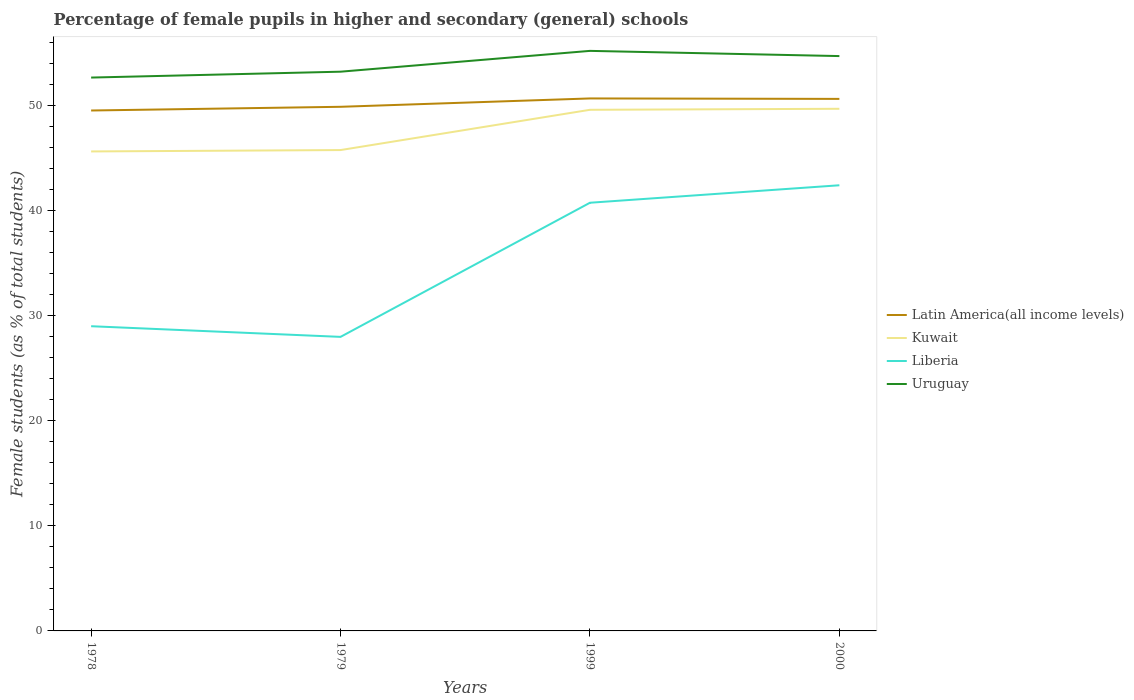How many different coloured lines are there?
Ensure brevity in your answer.  4. Does the line corresponding to Kuwait intersect with the line corresponding to Latin America(all income levels)?
Provide a succinct answer. No. Is the number of lines equal to the number of legend labels?
Provide a succinct answer. Yes. Across all years, what is the maximum percentage of female pupils in higher and secondary schools in Latin America(all income levels)?
Provide a short and direct response. 49.54. In which year was the percentage of female pupils in higher and secondary schools in Latin America(all income levels) maximum?
Ensure brevity in your answer.  1978. What is the total percentage of female pupils in higher and secondary schools in Liberia in the graph?
Ensure brevity in your answer.  -1.66. What is the difference between the highest and the second highest percentage of female pupils in higher and secondary schools in Latin America(all income levels)?
Offer a very short reply. 1.15. What is the difference between the highest and the lowest percentage of female pupils in higher and secondary schools in Kuwait?
Your answer should be compact. 2. Is the percentage of female pupils in higher and secondary schools in Uruguay strictly greater than the percentage of female pupils in higher and secondary schools in Latin America(all income levels) over the years?
Ensure brevity in your answer.  No. What is the difference between two consecutive major ticks on the Y-axis?
Keep it short and to the point. 10. Does the graph contain grids?
Ensure brevity in your answer.  No. Where does the legend appear in the graph?
Your answer should be compact. Center right. How many legend labels are there?
Give a very brief answer. 4. How are the legend labels stacked?
Provide a short and direct response. Vertical. What is the title of the graph?
Your response must be concise. Percentage of female pupils in higher and secondary (general) schools. Does "Guam" appear as one of the legend labels in the graph?
Your response must be concise. No. What is the label or title of the X-axis?
Your response must be concise. Years. What is the label or title of the Y-axis?
Your response must be concise. Female students (as % of total students). What is the Female students (as % of total students) of Latin America(all income levels) in 1978?
Give a very brief answer. 49.54. What is the Female students (as % of total students) of Kuwait in 1978?
Give a very brief answer. 45.65. What is the Female students (as % of total students) in Liberia in 1978?
Offer a very short reply. 29.01. What is the Female students (as % of total students) in Uruguay in 1978?
Your response must be concise. 52.68. What is the Female students (as % of total students) in Latin America(all income levels) in 1979?
Give a very brief answer. 49.89. What is the Female students (as % of total students) in Kuwait in 1979?
Ensure brevity in your answer.  45.78. What is the Female students (as % of total students) of Liberia in 1979?
Make the answer very short. 27.99. What is the Female students (as % of total students) in Uruguay in 1979?
Ensure brevity in your answer.  53.24. What is the Female students (as % of total students) of Latin America(all income levels) in 1999?
Offer a very short reply. 50.69. What is the Female students (as % of total students) of Kuwait in 1999?
Give a very brief answer. 49.61. What is the Female students (as % of total students) of Liberia in 1999?
Provide a short and direct response. 40.76. What is the Female students (as % of total students) in Uruguay in 1999?
Offer a terse response. 55.22. What is the Female students (as % of total students) of Latin America(all income levels) in 2000?
Give a very brief answer. 50.65. What is the Female students (as % of total students) of Kuwait in 2000?
Provide a succinct answer. 49.71. What is the Female students (as % of total students) of Liberia in 2000?
Offer a very short reply. 42.42. What is the Female students (as % of total students) in Uruguay in 2000?
Your answer should be very brief. 54.72. Across all years, what is the maximum Female students (as % of total students) of Latin America(all income levels)?
Your answer should be compact. 50.69. Across all years, what is the maximum Female students (as % of total students) of Kuwait?
Offer a terse response. 49.71. Across all years, what is the maximum Female students (as % of total students) in Liberia?
Ensure brevity in your answer.  42.42. Across all years, what is the maximum Female students (as % of total students) in Uruguay?
Provide a succinct answer. 55.22. Across all years, what is the minimum Female students (as % of total students) in Latin America(all income levels)?
Provide a succinct answer. 49.54. Across all years, what is the minimum Female students (as % of total students) in Kuwait?
Make the answer very short. 45.65. Across all years, what is the minimum Female students (as % of total students) in Liberia?
Ensure brevity in your answer.  27.99. Across all years, what is the minimum Female students (as % of total students) of Uruguay?
Provide a short and direct response. 52.68. What is the total Female students (as % of total students) of Latin America(all income levels) in the graph?
Your response must be concise. 200.78. What is the total Female students (as % of total students) of Kuwait in the graph?
Your response must be concise. 190.74. What is the total Female students (as % of total students) of Liberia in the graph?
Ensure brevity in your answer.  140.19. What is the total Female students (as % of total students) in Uruguay in the graph?
Keep it short and to the point. 215.86. What is the difference between the Female students (as % of total students) of Latin America(all income levels) in 1978 and that in 1979?
Provide a short and direct response. -0.35. What is the difference between the Female students (as % of total students) of Kuwait in 1978 and that in 1979?
Your answer should be very brief. -0.13. What is the difference between the Female students (as % of total students) of Liberia in 1978 and that in 1979?
Your answer should be compact. 1.01. What is the difference between the Female students (as % of total students) of Uruguay in 1978 and that in 1979?
Make the answer very short. -0.56. What is the difference between the Female students (as % of total students) in Latin America(all income levels) in 1978 and that in 1999?
Provide a succinct answer. -1.15. What is the difference between the Female students (as % of total students) in Kuwait in 1978 and that in 1999?
Provide a short and direct response. -3.96. What is the difference between the Female students (as % of total students) in Liberia in 1978 and that in 1999?
Offer a very short reply. -11.75. What is the difference between the Female students (as % of total students) in Uruguay in 1978 and that in 1999?
Offer a terse response. -2.54. What is the difference between the Female students (as % of total students) in Latin America(all income levels) in 1978 and that in 2000?
Keep it short and to the point. -1.11. What is the difference between the Female students (as % of total students) in Kuwait in 1978 and that in 2000?
Offer a terse response. -4.06. What is the difference between the Female students (as % of total students) in Liberia in 1978 and that in 2000?
Give a very brief answer. -13.42. What is the difference between the Female students (as % of total students) in Uruguay in 1978 and that in 2000?
Ensure brevity in your answer.  -2.05. What is the difference between the Female students (as % of total students) of Latin America(all income levels) in 1979 and that in 1999?
Your answer should be very brief. -0.8. What is the difference between the Female students (as % of total students) in Kuwait in 1979 and that in 1999?
Offer a terse response. -3.83. What is the difference between the Female students (as % of total students) in Liberia in 1979 and that in 1999?
Ensure brevity in your answer.  -12.77. What is the difference between the Female students (as % of total students) in Uruguay in 1979 and that in 1999?
Your answer should be very brief. -1.98. What is the difference between the Female students (as % of total students) of Latin America(all income levels) in 1979 and that in 2000?
Offer a terse response. -0.75. What is the difference between the Female students (as % of total students) of Kuwait in 1979 and that in 2000?
Your answer should be very brief. -3.93. What is the difference between the Female students (as % of total students) of Liberia in 1979 and that in 2000?
Provide a succinct answer. -14.43. What is the difference between the Female students (as % of total students) in Uruguay in 1979 and that in 2000?
Provide a succinct answer. -1.49. What is the difference between the Female students (as % of total students) in Latin America(all income levels) in 1999 and that in 2000?
Provide a short and direct response. 0.04. What is the difference between the Female students (as % of total students) of Kuwait in 1999 and that in 2000?
Keep it short and to the point. -0.1. What is the difference between the Female students (as % of total students) in Liberia in 1999 and that in 2000?
Offer a very short reply. -1.66. What is the difference between the Female students (as % of total students) in Uruguay in 1999 and that in 2000?
Your answer should be very brief. 0.49. What is the difference between the Female students (as % of total students) in Latin America(all income levels) in 1978 and the Female students (as % of total students) in Kuwait in 1979?
Provide a short and direct response. 3.77. What is the difference between the Female students (as % of total students) of Latin America(all income levels) in 1978 and the Female students (as % of total students) of Liberia in 1979?
Ensure brevity in your answer.  21.55. What is the difference between the Female students (as % of total students) in Latin America(all income levels) in 1978 and the Female students (as % of total students) in Uruguay in 1979?
Your response must be concise. -3.69. What is the difference between the Female students (as % of total students) in Kuwait in 1978 and the Female students (as % of total students) in Liberia in 1979?
Your response must be concise. 17.65. What is the difference between the Female students (as % of total students) in Kuwait in 1978 and the Female students (as % of total students) in Uruguay in 1979?
Your answer should be very brief. -7.59. What is the difference between the Female students (as % of total students) of Liberia in 1978 and the Female students (as % of total students) of Uruguay in 1979?
Provide a short and direct response. -24.23. What is the difference between the Female students (as % of total students) of Latin America(all income levels) in 1978 and the Female students (as % of total students) of Kuwait in 1999?
Offer a very short reply. -0.07. What is the difference between the Female students (as % of total students) in Latin America(all income levels) in 1978 and the Female students (as % of total students) in Liberia in 1999?
Provide a succinct answer. 8.78. What is the difference between the Female students (as % of total students) in Latin America(all income levels) in 1978 and the Female students (as % of total students) in Uruguay in 1999?
Your response must be concise. -5.68. What is the difference between the Female students (as % of total students) in Kuwait in 1978 and the Female students (as % of total students) in Liberia in 1999?
Provide a short and direct response. 4.88. What is the difference between the Female students (as % of total students) of Kuwait in 1978 and the Female students (as % of total students) of Uruguay in 1999?
Keep it short and to the point. -9.57. What is the difference between the Female students (as % of total students) of Liberia in 1978 and the Female students (as % of total students) of Uruguay in 1999?
Keep it short and to the point. -26.21. What is the difference between the Female students (as % of total students) in Latin America(all income levels) in 1978 and the Female students (as % of total students) in Kuwait in 2000?
Make the answer very short. -0.16. What is the difference between the Female students (as % of total students) of Latin America(all income levels) in 1978 and the Female students (as % of total students) of Liberia in 2000?
Keep it short and to the point. 7.12. What is the difference between the Female students (as % of total students) in Latin America(all income levels) in 1978 and the Female students (as % of total students) in Uruguay in 2000?
Offer a terse response. -5.18. What is the difference between the Female students (as % of total students) in Kuwait in 1978 and the Female students (as % of total students) in Liberia in 2000?
Give a very brief answer. 3.22. What is the difference between the Female students (as % of total students) in Kuwait in 1978 and the Female students (as % of total students) in Uruguay in 2000?
Ensure brevity in your answer.  -9.08. What is the difference between the Female students (as % of total students) of Liberia in 1978 and the Female students (as % of total students) of Uruguay in 2000?
Offer a very short reply. -25.72. What is the difference between the Female students (as % of total students) in Latin America(all income levels) in 1979 and the Female students (as % of total students) in Kuwait in 1999?
Your answer should be compact. 0.29. What is the difference between the Female students (as % of total students) of Latin America(all income levels) in 1979 and the Female students (as % of total students) of Liberia in 1999?
Your answer should be compact. 9.13. What is the difference between the Female students (as % of total students) of Latin America(all income levels) in 1979 and the Female students (as % of total students) of Uruguay in 1999?
Your answer should be very brief. -5.32. What is the difference between the Female students (as % of total students) of Kuwait in 1979 and the Female students (as % of total students) of Liberia in 1999?
Provide a succinct answer. 5.01. What is the difference between the Female students (as % of total students) of Kuwait in 1979 and the Female students (as % of total students) of Uruguay in 1999?
Provide a succinct answer. -9.44. What is the difference between the Female students (as % of total students) of Liberia in 1979 and the Female students (as % of total students) of Uruguay in 1999?
Your answer should be compact. -27.23. What is the difference between the Female students (as % of total students) in Latin America(all income levels) in 1979 and the Female students (as % of total students) in Kuwait in 2000?
Ensure brevity in your answer.  0.19. What is the difference between the Female students (as % of total students) of Latin America(all income levels) in 1979 and the Female students (as % of total students) of Liberia in 2000?
Your response must be concise. 7.47. What is the difference between the Female students (as % of total students) in Latin America(all income levels) in 1979 and the Female students (as % of total students) in Uruguay in 2000?
Offer a very short reply. -4.83. What is the difference between the Female students (as % of total students) in Kuwait in 1979 and the Female students (as % of total students) in Liberia in 2000?
Ensure brevity in your answer.  3.35. What is the difference between the Female students (as % of total students) of Kuwait in 1979 and the Female students (as % of total students) of Uruguay in 2000?
Keep it short and to the point. -8.95. What is the difference between the Female students (as % of total students) in Liberia in 1979 and the Female students (as % of total students) in Uruguay in 2000?
Keep it short and to the point. -26.73. What is the difference between the Female students (as % of total students) of Latin America(all income levels) in 1999 and the Female students (as % of total students) of Kuwait in 2000?
Your response must be concise. 0.98. What is the difference between the Female students (as % of total students) in Latin America(all income levels) in 1999 and the Female students (as % of total students) in Liberia in 2000?
Your response must be concise. 8.27. What is the difference between the Female students (as % of total students) of Latin America(all income levels) in 1999 and the Female students (as % of total students) of Uruguay in 2000?
Your answer should be compact. -4.03. What is the difference between the Female students (as % of total students) of Kuwait in 1999 and the Female students (as % of total students) of Liberia in 2000?
Make the answer very short. 7.18. What is the difference between the Female students (as % of total students) of Kuwait in 1999 and the Female students (as % of total students) of Uruguay in 2000?
Offer a very short reply. -5.11. What is the difference between the Female students (as % of total students) of Liberia in 1999 and the Female students (as % of total students) of Uruguay in 2000?
Provide a short and direct response. -13.96. What is the average Female students (as % of total students) in Latin America(all income levels) per year?
Give a very brief answer. 50.19. What is the average Female students (as % of total students) of Kuwait per year?
Keep it short and to the point. 47.68. What is the average Female students (as % of total students) in Liberia per year?
Give a very brief answer. 35.05. What is the average Female students (as % of total students) of Uruguay per year?
Offer a terse response. 53.96. In the year 1978, what is the difference between the Female students (as % of total students) in Latin America(all income levels) and Female students (as % of total students) in Kuwait?
Give a very brief answer. 3.9. In the year 1978, what is the difference between the Female students (as % of total students) of Latin America(all income levels) and Female students (as % of total students) of Liberia?
Your answer should be very brief. 20.54. In the year 1978, what is the difference between the Female students (as % of total students) in Latin America(all income levels) and Female students (as % of total students) in Uruguay?
Offer a very short reply. -3.14. In the year 1978, what is the difference between the Female students (as % of total students) of Kuwait and Female students (as % of total students) of Liberia?
Give a very brief answer. 16.64. In the year 1978, what is the difference between the Female students (as % of total students) of Kuwait and Female students (as % of total students) of Uruguay?
Keep it short and to the point. -7.03. In the year 1978, what is the difference between the Female students (as % of total students) in Liberia and Female students (as % of total students) in Uruguay?
Offer a very short reply. -23.67. In the year 1979, what is the difference between the Female students (as % of total students) of Latin America(all income levels) and Female students (as % of total students) of Kuwait?
Provide a short and direct response. 4.12. In the year 1979, what is the difference between the Female students (as % of total students) in Latin America(all income levels) and Female students (as % of total students) in Liberia?
Ensure brevity in your answer.  21.9. In the year 1979, what is the difference between the Female students (as % of total students) of Latin America(all income levels) and Female students (as % of total students) of Uruguay?
Provide a short and direct response. -3.34. In the year 1979, what is the difference between the Female students (as % of total students) of Kuwait and Female students (as % of total students) of Liberia?
Your answer should be very brief. 17.78. In the year 1979, what is the difference between the Female students (as % of total students) of Kuwait and Female students (as % of total students) of Uruguay?
Provide a succinct answer. -7.46. In the year 1979, what is the difference between the Female students (as % of total students) in Liberia and Female students (as % of total students) in Uruguay?
Offer a terse response. -25.24. In the year 1999, what is the difference between the Female students (as % of total students) in Latin America(all income levels) and Female students (as % of total students) in Kuwait?
Keep it short and to the point. 1.08. In the year 1999, what is the difference between the Female students (as % of total students) in Latin America(all income levels) and Female students (as % of total students) in Liberia?
Offer a terse response. 9.93. In the year 1999, what is the difference between the Female students (as % of total students) of Latin America(all income levels) and Female students (as % of total students) of Uruguay?
Provide a short and direct response. -4.53. In the year 1999, what is the difference between the Female students (as % of total students) in Kuwait and Female students (as % of total students) in Liberia?
Provide a succinct answer. 8.85. In the year 1999, what is the difference between the Female students (as % of total students) in Kuwait and Female students (as % of total students) in Uruguay?
Your answer should be very brief. -5.61. In the year 1999, what is the difference between the Female students (as % of total students) of Liberia and Female students (as % of total students) of Uruguay?
Provide a short and direct response. -14.46. In the year 2000, what is the difference between the Female students (as % of total students) in Latin America(all income levels) and Female students (as % of total students) in Kuwait?
Make the answer very short. 0.94. In the year 2000, what is the difference between the Female students (as % of total students) in Latin America(all income levels) and Female students (as % of total students) in Liberia?
Make the answer very short. 8.22. In the year 2000, what is the difference between the Female students (as % of total students) of Latin America(all income levels) and Female students (as % of total students) of Uruguay?
Your response must be concise. -4.08. In the year 2000, what is the difference between the Female students (as % of total students) of Kuwait and Female students (as % of total students) of Liberia?
Provide a succinct answer. 7.28. In the year 2000, what is the difference between the Female students (as % of total students) of Kuwait and Female students (as % of total students) of Uruguay?
Your answer should be very brief. -5.02. In the year 2000, what is the difference between the Female students (as % of total students) in Liberia and Female students (as % of total students) in Uruguay?
Your response must be concise. -12.3. What is the ratio of the Female students (as % of total students) in Latin America(all income levels) in 1978 to that in 1979?
Your response must be concise. 0.99. What is the ratio of the Female students (as % of total students) of Kuwait in 1978 to that in 1979?
Your answer should be compact. 1. What is the ratio of the Female students (as % of total students) in Liberia in 1978 to that in 1979?
Offer a very short reply. 1.04. What is the ratio of the Female students (as % of total students) in Latin America(all income levels) in 1978 to that in 1999?
Provide a succinct answer. 0.98. What is the ratio of the Female students (as % of total students) of Kuwait in 1978 to that in 1999?
Your response must be concise. 0.92. What is the ratio of the Female students (as % of total students) in Liberia in 1978 to that in 1999?
Make the answer very short. 0.71. What is the ratio of the Female students (as % of total students) in Uruguay in 1978 to that in 1999?
Your response must be concise. 0.95. What is the ratio of the Female students (as % of total students) in Latin America(all income levels) in 1978 to that in 2000?
Your response must be concise. 0.98. What is the ratio of the Female students (as % of total students) in Kuwait in 1978 to that in 2000?
Make the answer very short. 0.92. What is the ratio of the Female students (as % of total students) in Liberia in 1978 to that in 2000?
Keep it short and to the point. 0.68. What is the ratio of the Female students (as % of total students) of Uruguay in 1978 to that in 2000?
Your response must be concise. 0.96. What is the ratio of the Female students (as % of total students) of Latin America(all income levels) in 1979 to that in 1999?
Ensure brevity in your answer.  0.98. What is the ratio of the Female students (as % of total students) in Kuwait in 1979 to that in 1999?
Give a very brief answer. 0.92. What is the ratio of the Female students (as % of total students) in Liberia in 1979 to that in 1999?
Your answer should be very brief. 0.69. What is the ratio of the Female students (as % of total students) in Uruguay in 1979 to that in 1999?
Keep it short and to the point. 0.96. What is the ratio of the Female students (as % of total students) in Latin America(all income levels) in 1979 to that in 2000?
Make the answer very short. 0.99. What is the ratio of the Female students (as % of total students) in Kuwait in 1979 to that in 2000?
Offer a terse response. 0.92. What is the ratio of the Female students (as % of total students) in Liberia in 1979 to that in 2000?
Keep it short and to the point. 0.66. What is the ratio of the Female students (as % of total students) in Uruguay in 1979 to that in 2000?
Keep it short and to the point. 0.97. What is the ratio of the Female students (as % of total students) in Kuwait in 1999 to that in 2000?
Your response must be concise. 1. What is the ratio of the Female students (as % of total students) in Liberia in 1999 to that in 2000?
Give a very brief answer. 0.96. What is the difference between the highest and the second highest Female students (as % of total students) of Latin America(all income levels)?
Give a very brief answer. 0.04. What is the difference between the highest and the second highest Female students (as % of total students) of Kuwait?
Provide a short and direct response. 0.1. What is the difference between the highest and the second highest Female students (as % of total students) of Liberia?
Your answer should be very brief. 1.66. What is the difference between the highest and the second highest Female students (as % of total students) of Uruguay?
Give a very brief answer. 0.49. What is the difference between the highest and the lowest Female students (as % of total students) in Latin America(all income levels)?
Provide a succinct answer. 1.15. What is the difference between the highest and the lowest Female students (as % of total students) of Kuwait?
Offer a very short reply. 4.06. What is the difference between the highest and the lowest Female students (as % of total students) in Liberia?
Provide a succinct answer. 14.43. What is the difference between the highest and the lowest Female students (as % of total students) of Uruguay?
Offer a terse response. 2.54. 